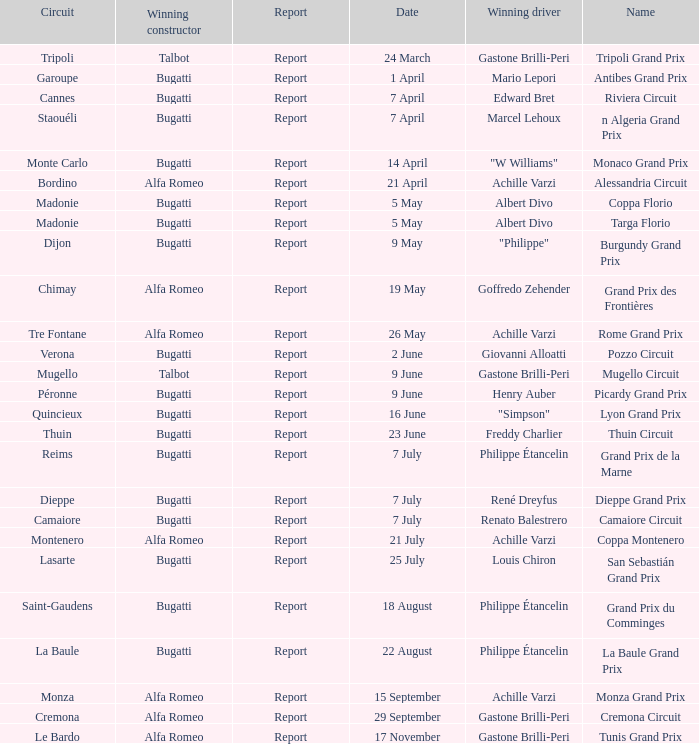What Name has a Winning constructor of bugatti, and a Winning driver of louis chiron? San Sebastián Grand Prix. 